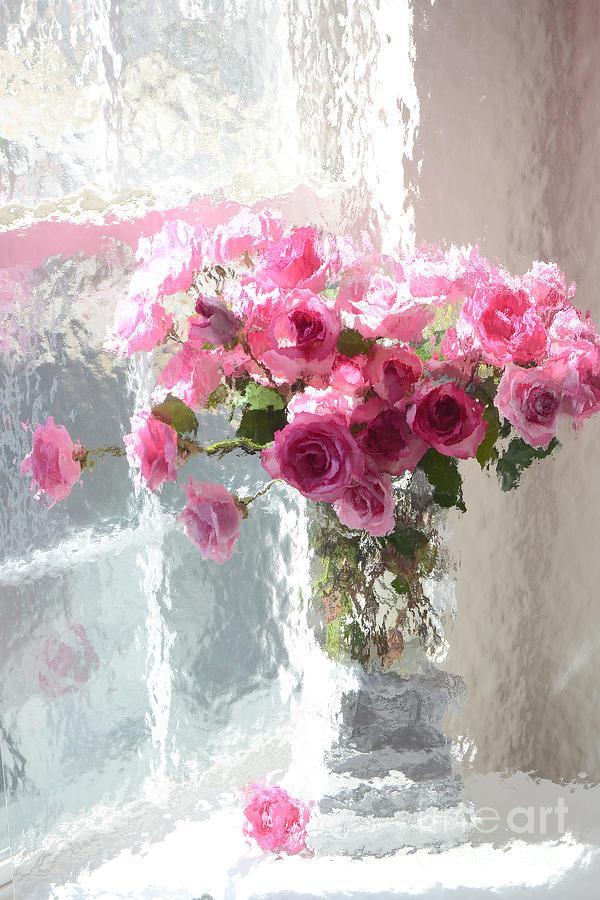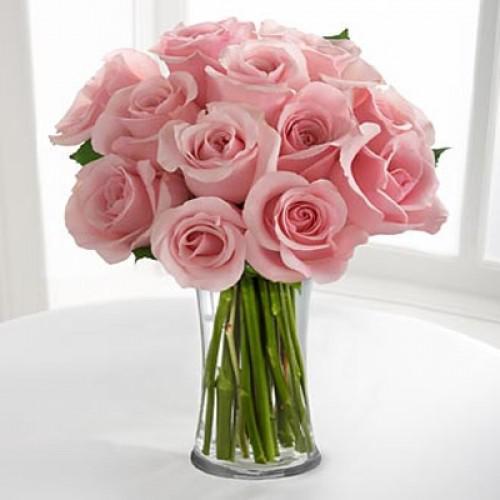The first image is the image on the left, the second image is the image on the right. For the images shown, is this caption "A bunch of green stems are visible through the glass in the vase on the right." true? Answer yes or no. Yes. 